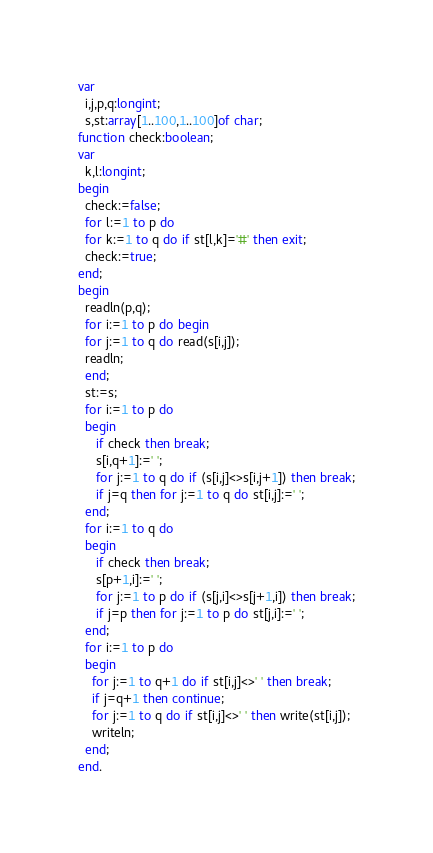<code> <loc_0><loc_0><loc_500><loc_500><_Pascal_>var
  i,j,p,q:longint;
  s,st:array[1..100,1..100]of char;
function check:boolean;
var
  k,l:longint;
begin
  check:=false;
  for l:=1 to p do
  for k:=1 to q do if st[l,k]='#' then exit;
  check:=true;
end;
begin
  readln(p,q);
  for i:=1 to p do begin
  for j:=1 to q do read(s[i,j]);
  readln;
  end;
  st:=s;
  for i:=1 to p do
  begin
     if check then break;
     s[i,q+1]:=' ';
	 for j:=1 to q do if (s[i,j]<>s[i,j+1]) then break;
	 if j=q then for j:=1 to q do st[i,j]:=' ';
  end;
  for i:=1 to q do
  begin
     if check then break;
     s[p+1,i]:=' ';
	 for j:=1 to p do if (s[j,i]<>s[j+1,i]) then break;
	 if j=p then for j:=1 to p do st[j,i]:=' ';
  end;
  for i:=1 to p do
  begin
	for j:=1 to q+1 do if st[i,j]<>' ' then break;
	if j=q+1 then continue;
    for j:=1 to q do if st[i,j]<>' ' then write(st[i,j]);
	writeln;
  end;
end.</code> 